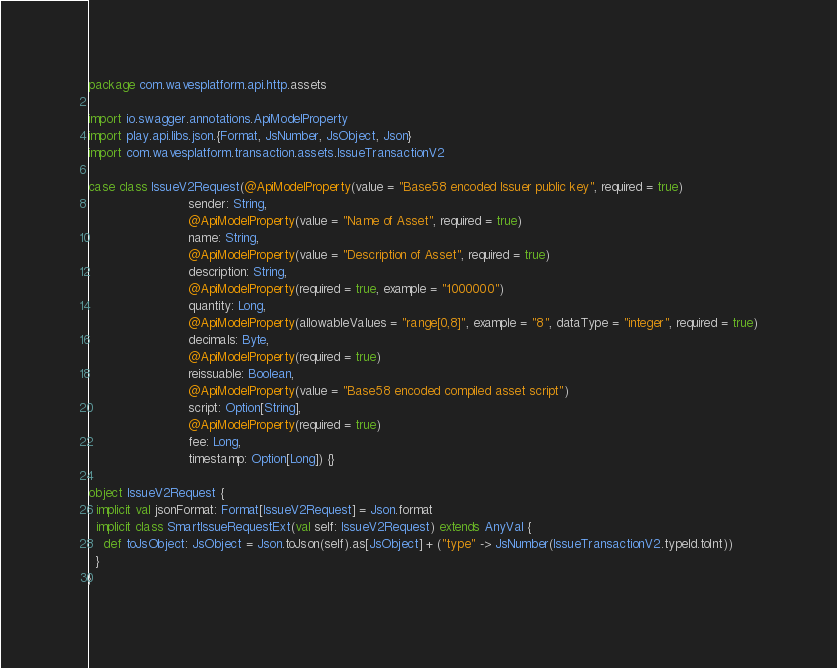Convert code to text. <code><loc_0><loc_0><loc_500><loc_500><_Scala_>package com.wavesplatform.api.http.assets

import io.swagger.annotations.ApiModelProperty
import play.api.libs.json.{Format, JsNumber, JsObject, Json}
import com.wavesplatform.transaction.assets.IssueTransactionV2

case class IssueV2Request(@ApiModelProperty(value = "Base58 encoded Issuer public key", required = true)
                          sender: String,
                          @ApiModelProperty(value = "Name of Asset", required = true)
                          name: String,
                          @ApiModelProperty(value = "Description of Asset", required = true)
                          description: String,
                          @ApiModelProperty(required = true, example = "1000000")
                          quantity: Long,
                          @ApiModelProperty(allowableValues = "range[0,8]", example = "8", dataType = "integer", required = true)
                          decimals: Byte,
                          @ApiModelProperty(required = true)
                          reissuable: Boolean,
                          @ApiModelProperty(value = "Base58 encoded compiled asset script")
                          script: Option[String],
                          @ApiModelProperty(required = true)
                          fee: Long,
                          timestamp: Option[Long]) {}

object IssueV2Request {
  implicit val jsonFormat: Format[IssueV2Request] = Json.format
  implicit class SmartIssueRequestExt(val self: IssueV2Request) extends AnyVal {
    def toJsObject: JsObject = Json.toJson(self).as[JsObject] + ("type" -> JsNumber(IssueTransactionV2.typeId.toInt))
  }
}
</code> 